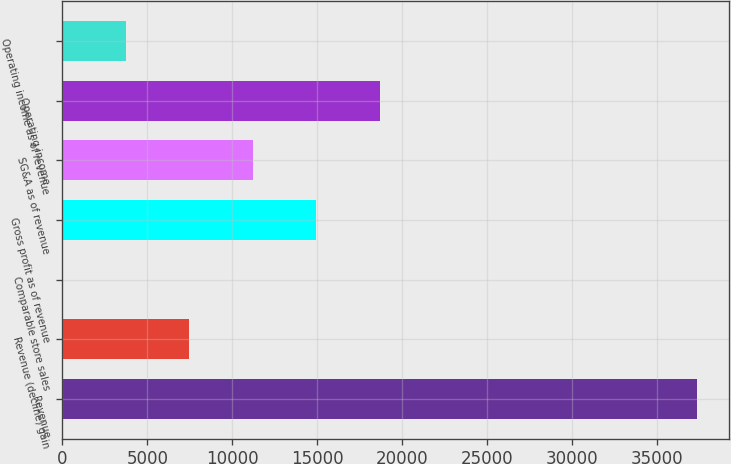Convert chart. <chart><loc_0><loc_0><loc_500><loc_500><bar_chart><fcel>Revenue<fcel>Revenue (decline) gain<fcel>Comparable store sales<fcel>Gross profit as of revenue<fcel>SG&A as of revenue<fcel>Operating income<fcel>Operating income as of revenue<nl><fcel>37314<fcel>7464.16<fcel>1.7<fcel>14926.6<fcel>11195.4<fcel>18657.8<fcel>3732.93<nl></chart> 